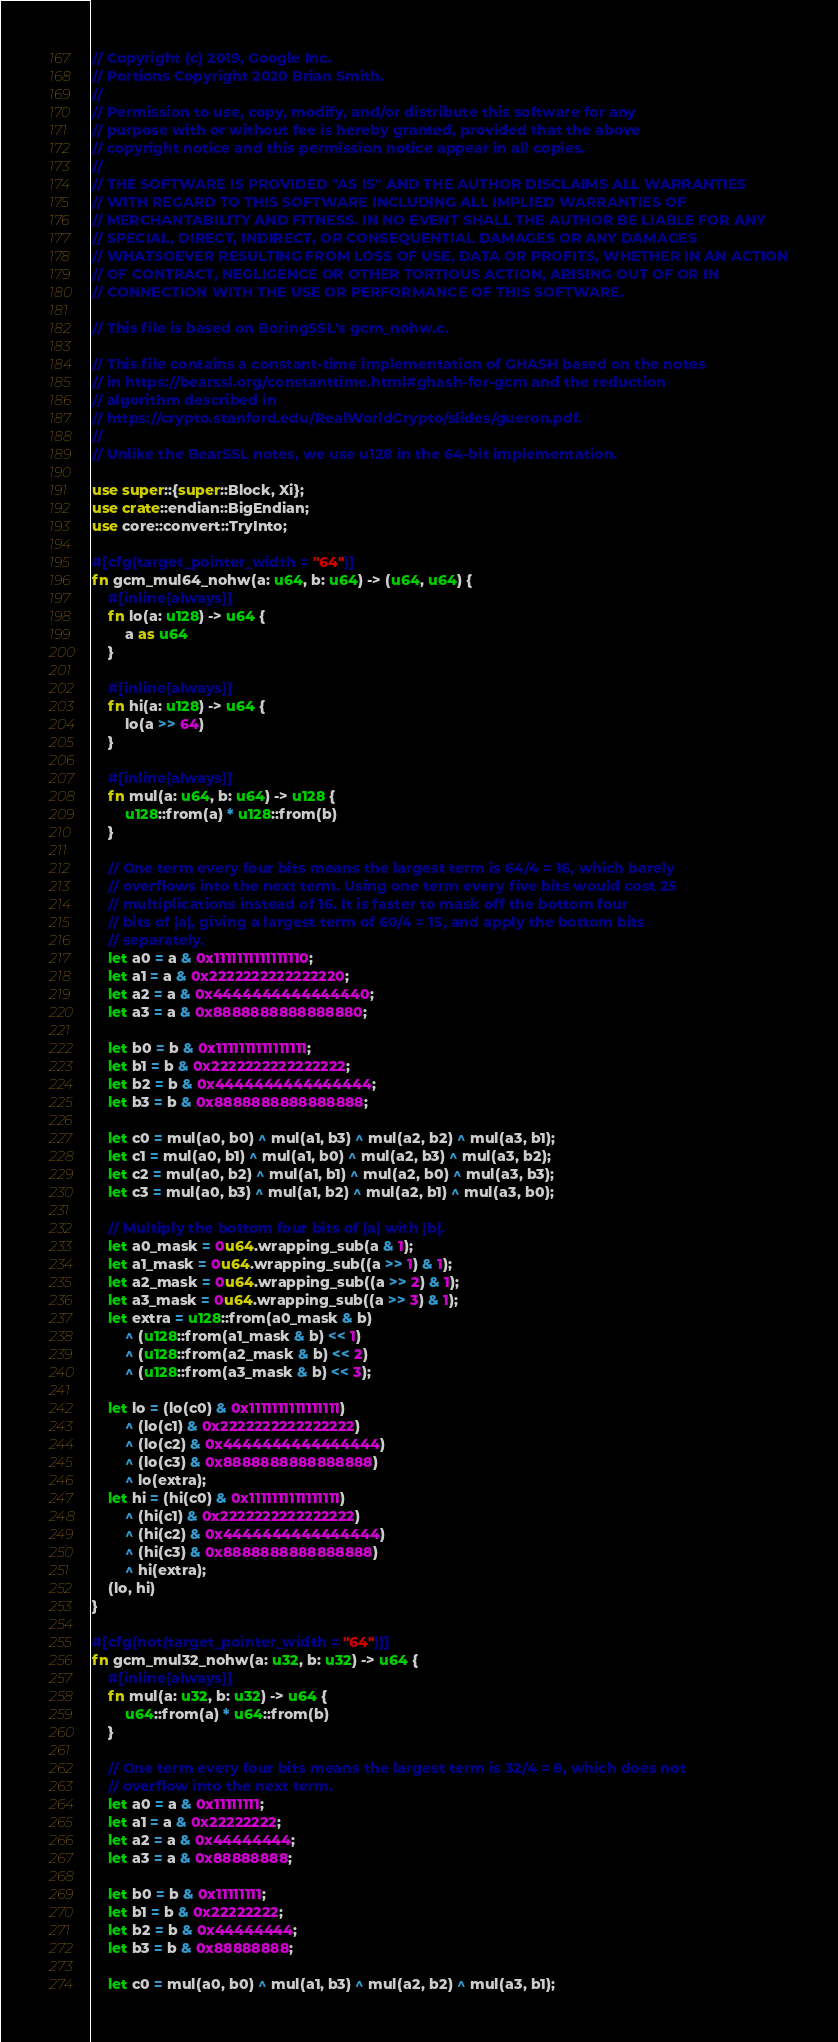<code> <loc_0><loc_0><loc_500><loc_500><_Rust_>// Copyright (c) 2019, Google Inc.
// Portions Copyright 2020 Brian Smith.
//
// Permission to use, copy, modify, and/or distribute this software for any
// purpose with or without fee is hereby granted, provided that the above
// copyright notice and this permission notice appear in all copies.
//
// THE SOFTWARE IS PROVIDED "AS IS" AND THE AUTHOR DISCLAIMS ALL WARRANTIES
// WITH REGARD TO THIS SOFTWARE INCLUDING ALL IMPLIED WARRANTIES OF
// MERCHANTABILITY AND FITNESS. IN NO EVENT SHALL THE AUTHOR BE LIABLE FOR ANY
// SPECIAL, DIRECT, INDIRECT, OR CONSEQUENTIAL DAMAGES OR ANY DAMAGES
// WHATSOEVER RESULTING FROM LOSS OF USE, DATA OR PROFITS, WHETHER IN AN ACTION
// OF CONTRACT, NEGLIGENCE OR OTHER TORTIOUS ACTION, ARISING OUT OF OR IN
// CONNECTION WITH THE USE OR PERFORMANCE OF THIS SOFTWARE.

// This file is based on BoringSSL's gcm_nohw.c.

// This file contains a constant-time implementation of GHASH based on the notes
// in https://bearssl.org/constanttime.html#ghash-for-gcm and the reduction
// algorithm described in
// https://crypto.stanford.edu/RealWorldCrypto/slides/gueron.pdf.
//
// Unlike the BearSSL notes, we use u128 in the 64-bit implementation.

use super::{super::Block, Xi};
use crate::endian::BigEndian;
use core::convert::TryInto;

#[cfg(target_pointer_width = "64")]
fn gcm_mul64_nohw(a: u64, b: u64) -> (u64, u64) {
    #[inline(always)]
    fn lo(a: u128) -> u64 {
        a as u64
    }

    #[inline(always)]
    fn hi(a: u128) -> u64 {
        lo(a >> 64)
    }

    #[inline(always)]
    fn mul(a: u64, b: u64) -> u128 {
        u128::from(a) * u128::from(b)
    }

    // One term every four bits means the largest term is 64/4 = 16, which barely
    // overflows into the next term. Using one term every five bits would cost 25
    // multiplications instead of 16. It is faster to mask off the bottom four
    // bits of |a|, giving a largest term of 60/4 = 15, and apply the bottom bits
    // separately.
    let a0 = a & 0x1111111111111110;
    let a1 = a & 0x2222222222222220;
    let a2 = a & 0x4444444444444440;
    let a3 = a & 0x8888888888888880;

    let b0 = b & 0x1111111111111111;
    let b1 = b & 0x2222222222222222;
    let b2 = b & 0x4444444444444444;
    let b3 = b & 0x8888888888888888;

    let c0 = mul(a0, b0) ^ mul(a1, b3) ^ mul(a2, b2) ^ mul(a3, b1);
    let c1 = mul(a0, b1) ^ mul(a1, b0) ^ mul(a2, b3) ^ mul(a3, b2);
    let c2 = mul(a0, b2) ^ mul(a1, b1) ^ mul(a2, b0) ^ mul(a3, b3);
    let c3 = mul(a0, b3) ^ mul(a1, b2) ^ mul(a2, b1) ^ mul(a3, b0);

    // Multiply the bottom four bits of |a| with |b|.
    let a0_mask = 0u64.wrapping_sub(a & 1);
    let a1_mask = 0u64.wrapping_sub((a >> 1) & 1);
    let a2_mask = 0u64.wrapping_sub((a >> 2) & 1);
    let a3_mask = 0u64.wrapping_sub((a >> 3) & 1);
    let extra = u128::from(a0_mask & b)
        ^ (u128::from(a1_mask & b) << 1)
        ^ (u128::from(a2_mask & b) << 2)
        ^ (u128::from(a3_mask & b) << 3);

    let lo = (lo(c0) & 0x1111111111111111)
        ^ (lo(c1) & 0x2222222222222222)
        ^ (lo(c2) & 0x4444444444444444)
        ^ (lo(c3) & 0x8888888888888888)
        ^ lo(extra);
    let hi = (hi(c0) & 0x1111111111111111)
        ^ (hi(c1) & 0x2222222222222222)
        ^ (hi(c2) & 0x4444444444444444)
        ^ (hi(c3) & 0x8888888888888888)
        ^ hi(extra);
    (lo, hi)
}

#[cfg(not(target_pointer_width = "64"))]
fn gcm_mul32_nohw(a: u32, b: u32) -> u64 {
    #[inline(always)]
    fn mul(a: u32, b: u32) -> u64 {
        u64::from(a) * u64::from(b)
    }

    // One term every four bits means the largest term is 32/4 = 8, which does not
    // overflow into the next term.
    let a0 = a & 0x11111111;
    let a1 = a & 0x22222222;
    let a2 = a & 0x44444444;
    let a3 = a & 0x88888888;

    let b0 = b & 0x11111111;
    let b1 = b & 0x22222222;
    let b2 = b & 0x44444444;
    let b3 = b & 0x88888888;

    let c0 = mul(a0, b0) ^ mul(a1, b3) ^ mul(a2, b2) ^ mul(a3, b1);</code> 